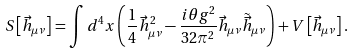Convert formula to latex. <formula><loc_0><loc_0><loc_500><loc_500>S \left [ \vec { h } _ { \mu \nu } \right ] = \int d ^ { 4 } x \left ( \frac { 1 } { 4 } \vec { h } _ { \mu \nu } ^ { 2 } - \frac { i \theta g ^ { 2 } } { 3 2 \pi ^ { 2 } } \vec { h } _ { \mu \nu } \tilde { \vec { h } } _ { \mu \nu } \right ) + V \left [ \vec { h } _ { \mu \nu } \right ] .</formula> 